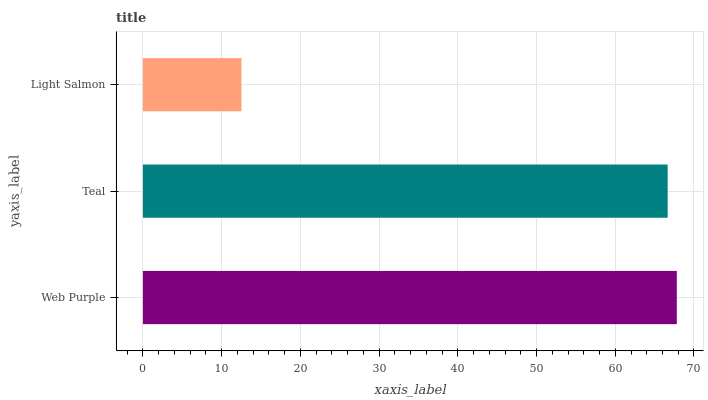Is Light Salmon the minimum?
Answer yes or no. Yes. Is Web Purple the maximum?
Answer yes or no. Yes. Is Teal the minimum?
Answer yes or no. No. Is Teal the maximum?
Answer yes or no. No. Is Web Purple greater than Teal?
Answer yes or no. Yes. Is Teal less than Web Purple?
Answer yes or no. Yes. Is Teal greater than Web Purple?
Answer yes or no. No. Is Web Purple less than Teal?
Answer yes or no. No. Is Teal the high median?
Answer yes or no. Yes. Is Teal the low median?
Answer yes or no. Yes. Is Web Purple the high median?
Answer yes or no. No. Is Web Purple the low median?
Answer yes or no. No. 